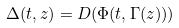<formula> <loc_0><loc_0><loc_500><loc_500>\Delta ( t , z ) = D ( \Phi ( t , \Gamma ( z ) ) )</formula> 